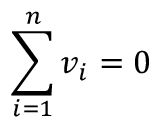Convert formula to latex. <formula><loc_0><loc_0><loc_500><loc_500>\sum _ { i = 1 } ^ { n } v _ { i } = 0</formula> 